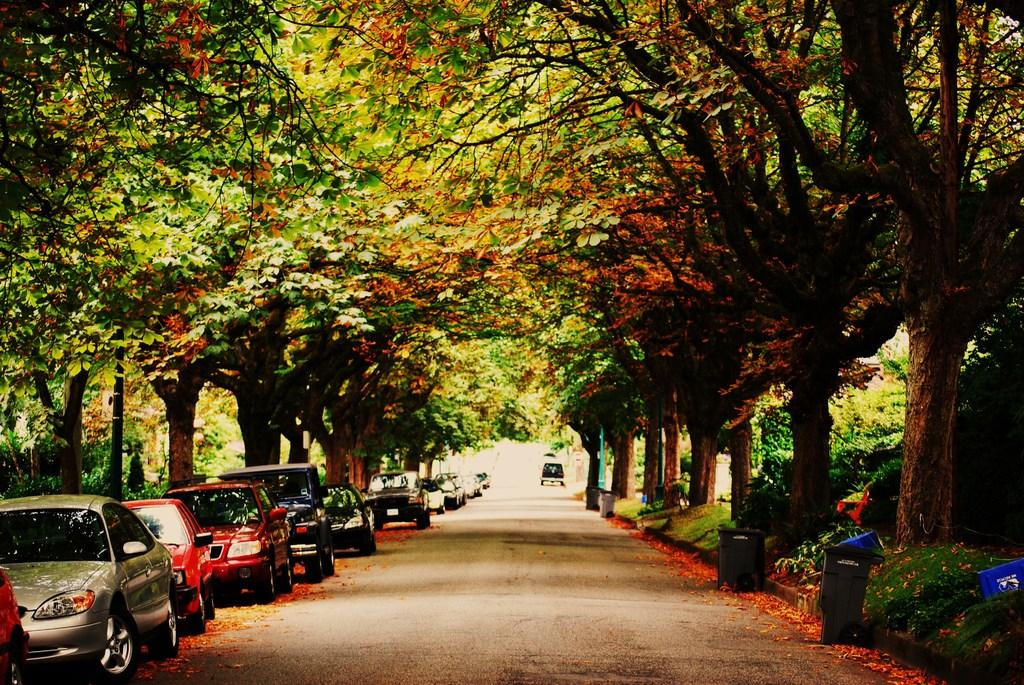What types of objects can be seen in the image? There are vehicles and dustbins in the image. What type of natural environment is visible in the image? There is grass, plants, and trees in the image. Can you describe the setting where the vehicles and dustbins are located? The setting includes grass, plants, and trees, suggesting it might be an outdoor area. What type of swing can be seen in the image? There is no swing present in the image. 